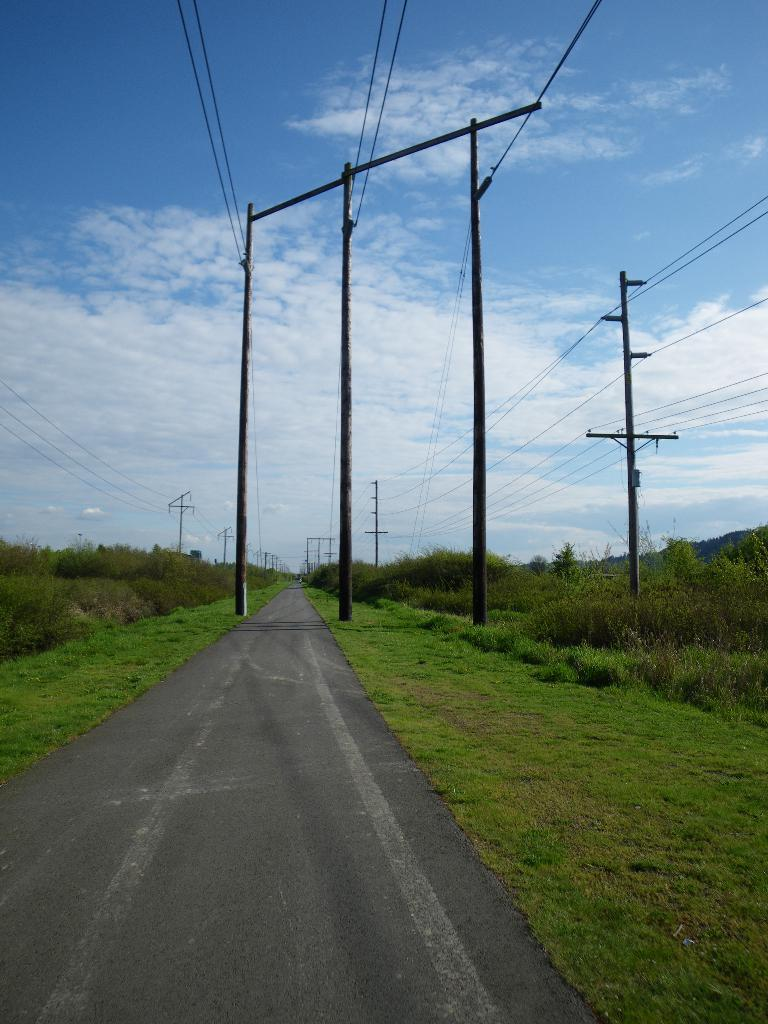What is located in the center of the image? There are poles and wires in the center of the image. What can be seen in the background of the image? There are plants in the background of the image. What type of vegetation is on the ground in the front of the image? There is grass on the ground in the front of the image. How would you describe the sky in the image? The sky is cloudy in the image. What is the title of the volleyball game happening in the image? There is no volleyball game present in the image, so there is no title to be determined. 